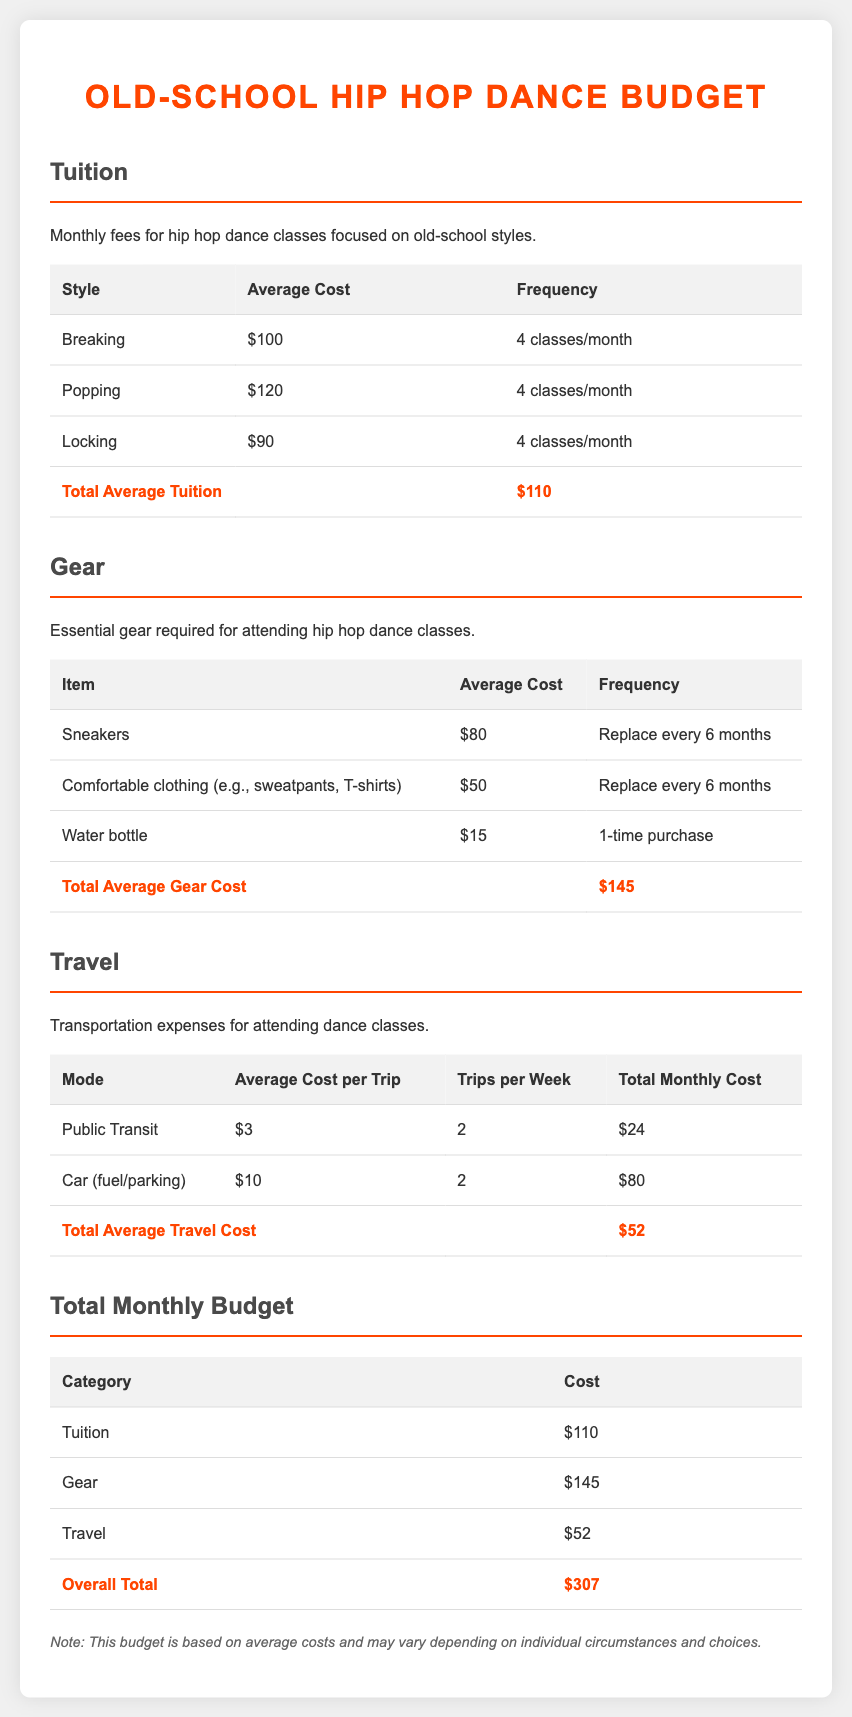What is the average cost of breaking classes? The average cost of breaking classes is listed in the tuition section, which is $100.
Answer: $100 What is the total average gear cost? The total average gear cost is shown in the gear section, which totals $145.
Answer: $145 How many classes are included for popping? The frequency for popping is indicated in the tuition section, stating it is 4 classes per month.
Answer: 4 classes/month What is the average cost per trip for public transit? The average cost per trip for public transit is specified in the travel section, which is $3.
Answer: $3 What is the overall total of the monthly budget? The overall total is detailed in the total monthly budget section, which is $307.
Answer: $307 How often do you replace sneakers? The document states that sneakers should be replaced every 6 months as listed in the gear section.
Answer: Every 6 months What is the cost of transportation by car per trip? The cost of transportation by car per trip is provided in the travel section, which is $10.
Answer: $10 How many trips per week are accounted for in the budget? The travel budget accounts for 2 trips per week for both public transit and car travel, as noted in the travel tables.
Answer: 2 trips/week 